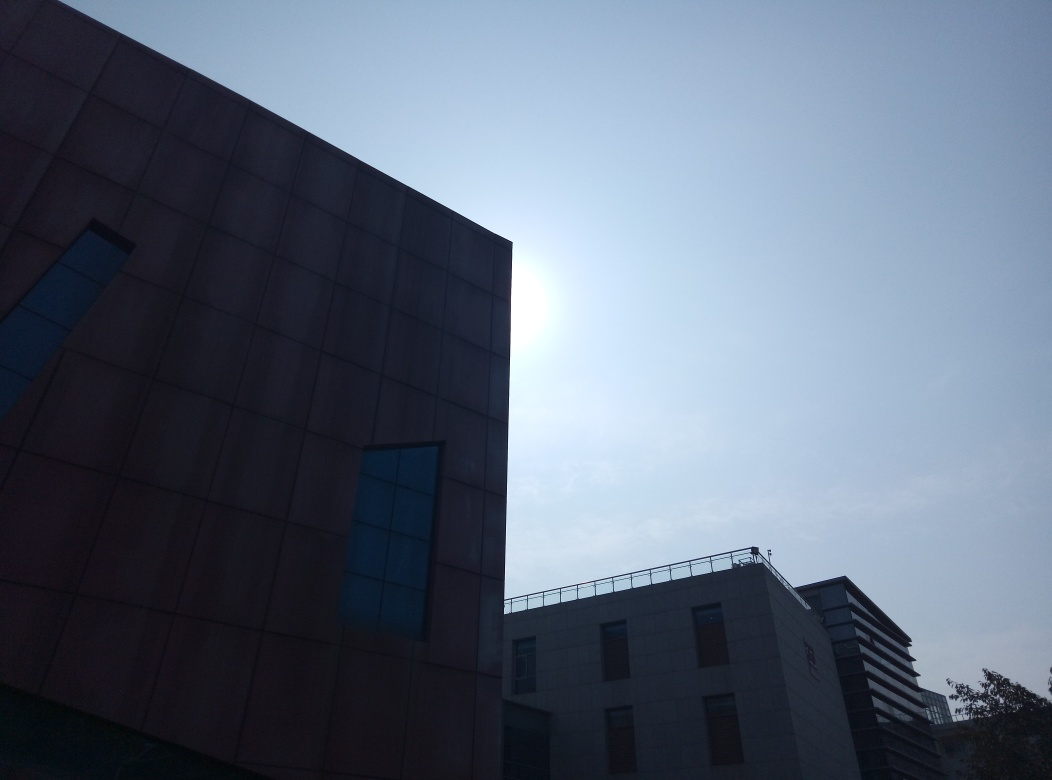What architectural styles can you identify in the buildings pictured? The architecture of the buildings in the image seems modern, with a minimalistic design. The building on the left features an asymmetrical shape and metallic cladding, while the building on the right has a more conventional boxy shape with a flat facade and windows arranged in a regular grid pattern. 